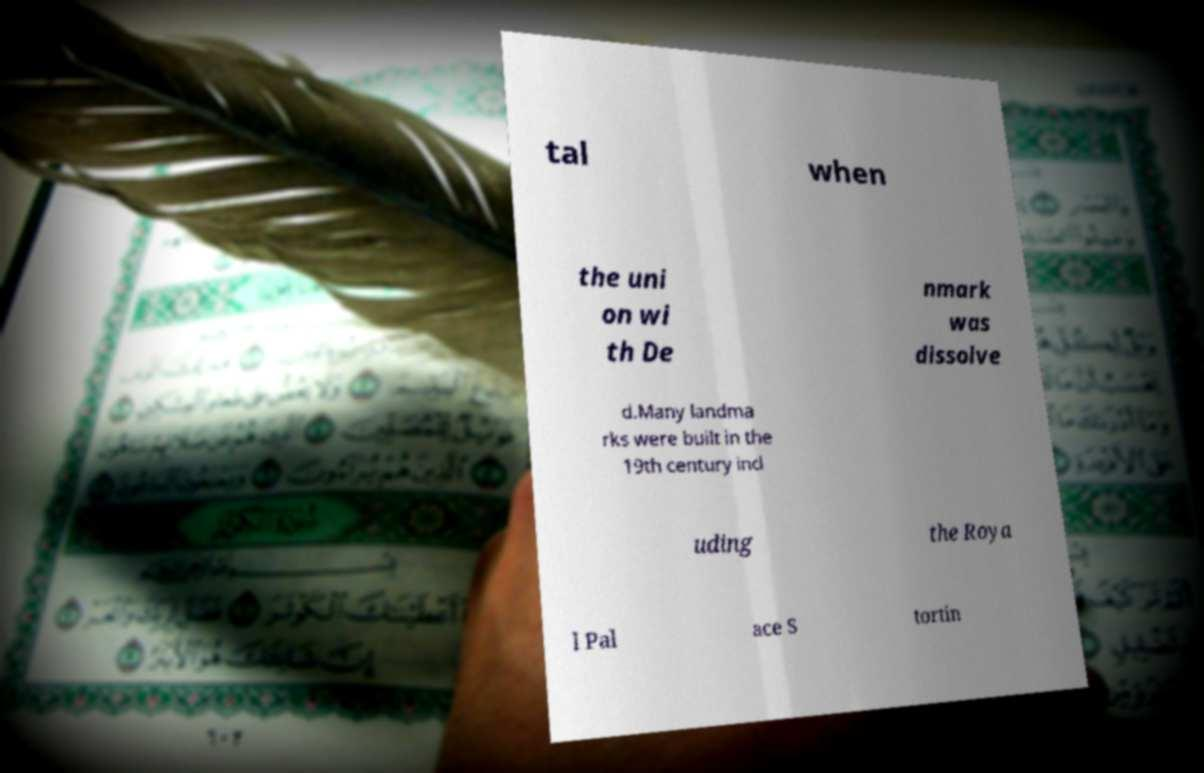Please read and relay the text visible in this image. What does it say? tal when the uni on wi th De nmark was dissolve d.Many landma rks were built in the 19th century incl uding the Roya l Pal ace S tortin 